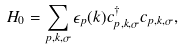<formula> <loc_0><loc_0><loc_500><loc_500>H _ { 0 } & = \sum _ { p , k , \sigma } \epsilon _ { p } ( k ) c _ { p , k , \sigma } ^ { \dagger } c _ { p , k , \sigma } ,</formula> 